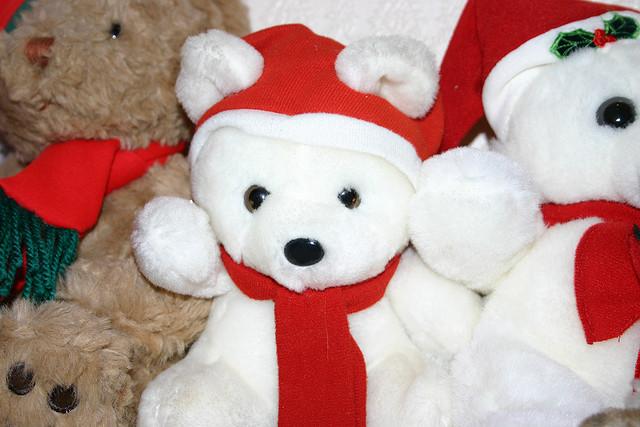How many white bears are there?
Quick response, please. 2. How many white bears are in this scene?
Keep it brief. 2. Are these bears dressed for Christmas?
Give a very brief answer. Yes. 